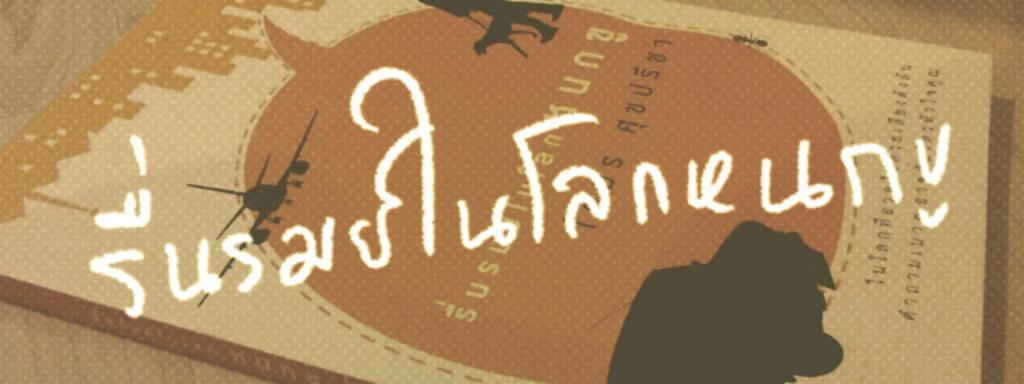What object is present in the image? There is a book in the image. What is the book placed on? The book is on a cream-colored surface. Can you describe any text or markings on the book? Yes, there is writing on the book. What type of attraction can be seen in the background of the image? There is no attraction visible in the image; it only features a book on a cream-colored surface. 